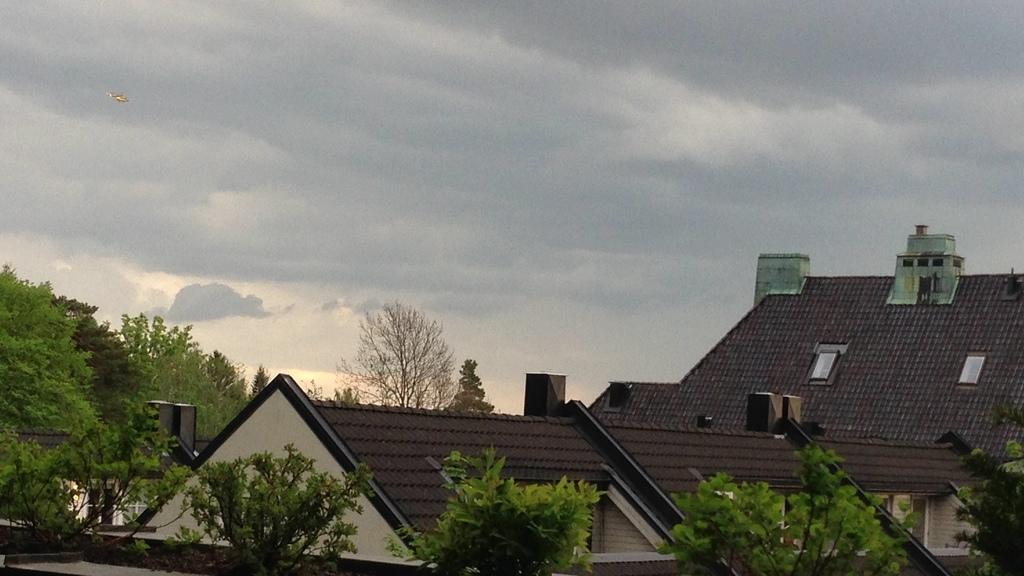Can you describe this image briefly? In the image we can see there are trees and there are buildings. There is an aircraft in the air and there is a cloudy sky. 